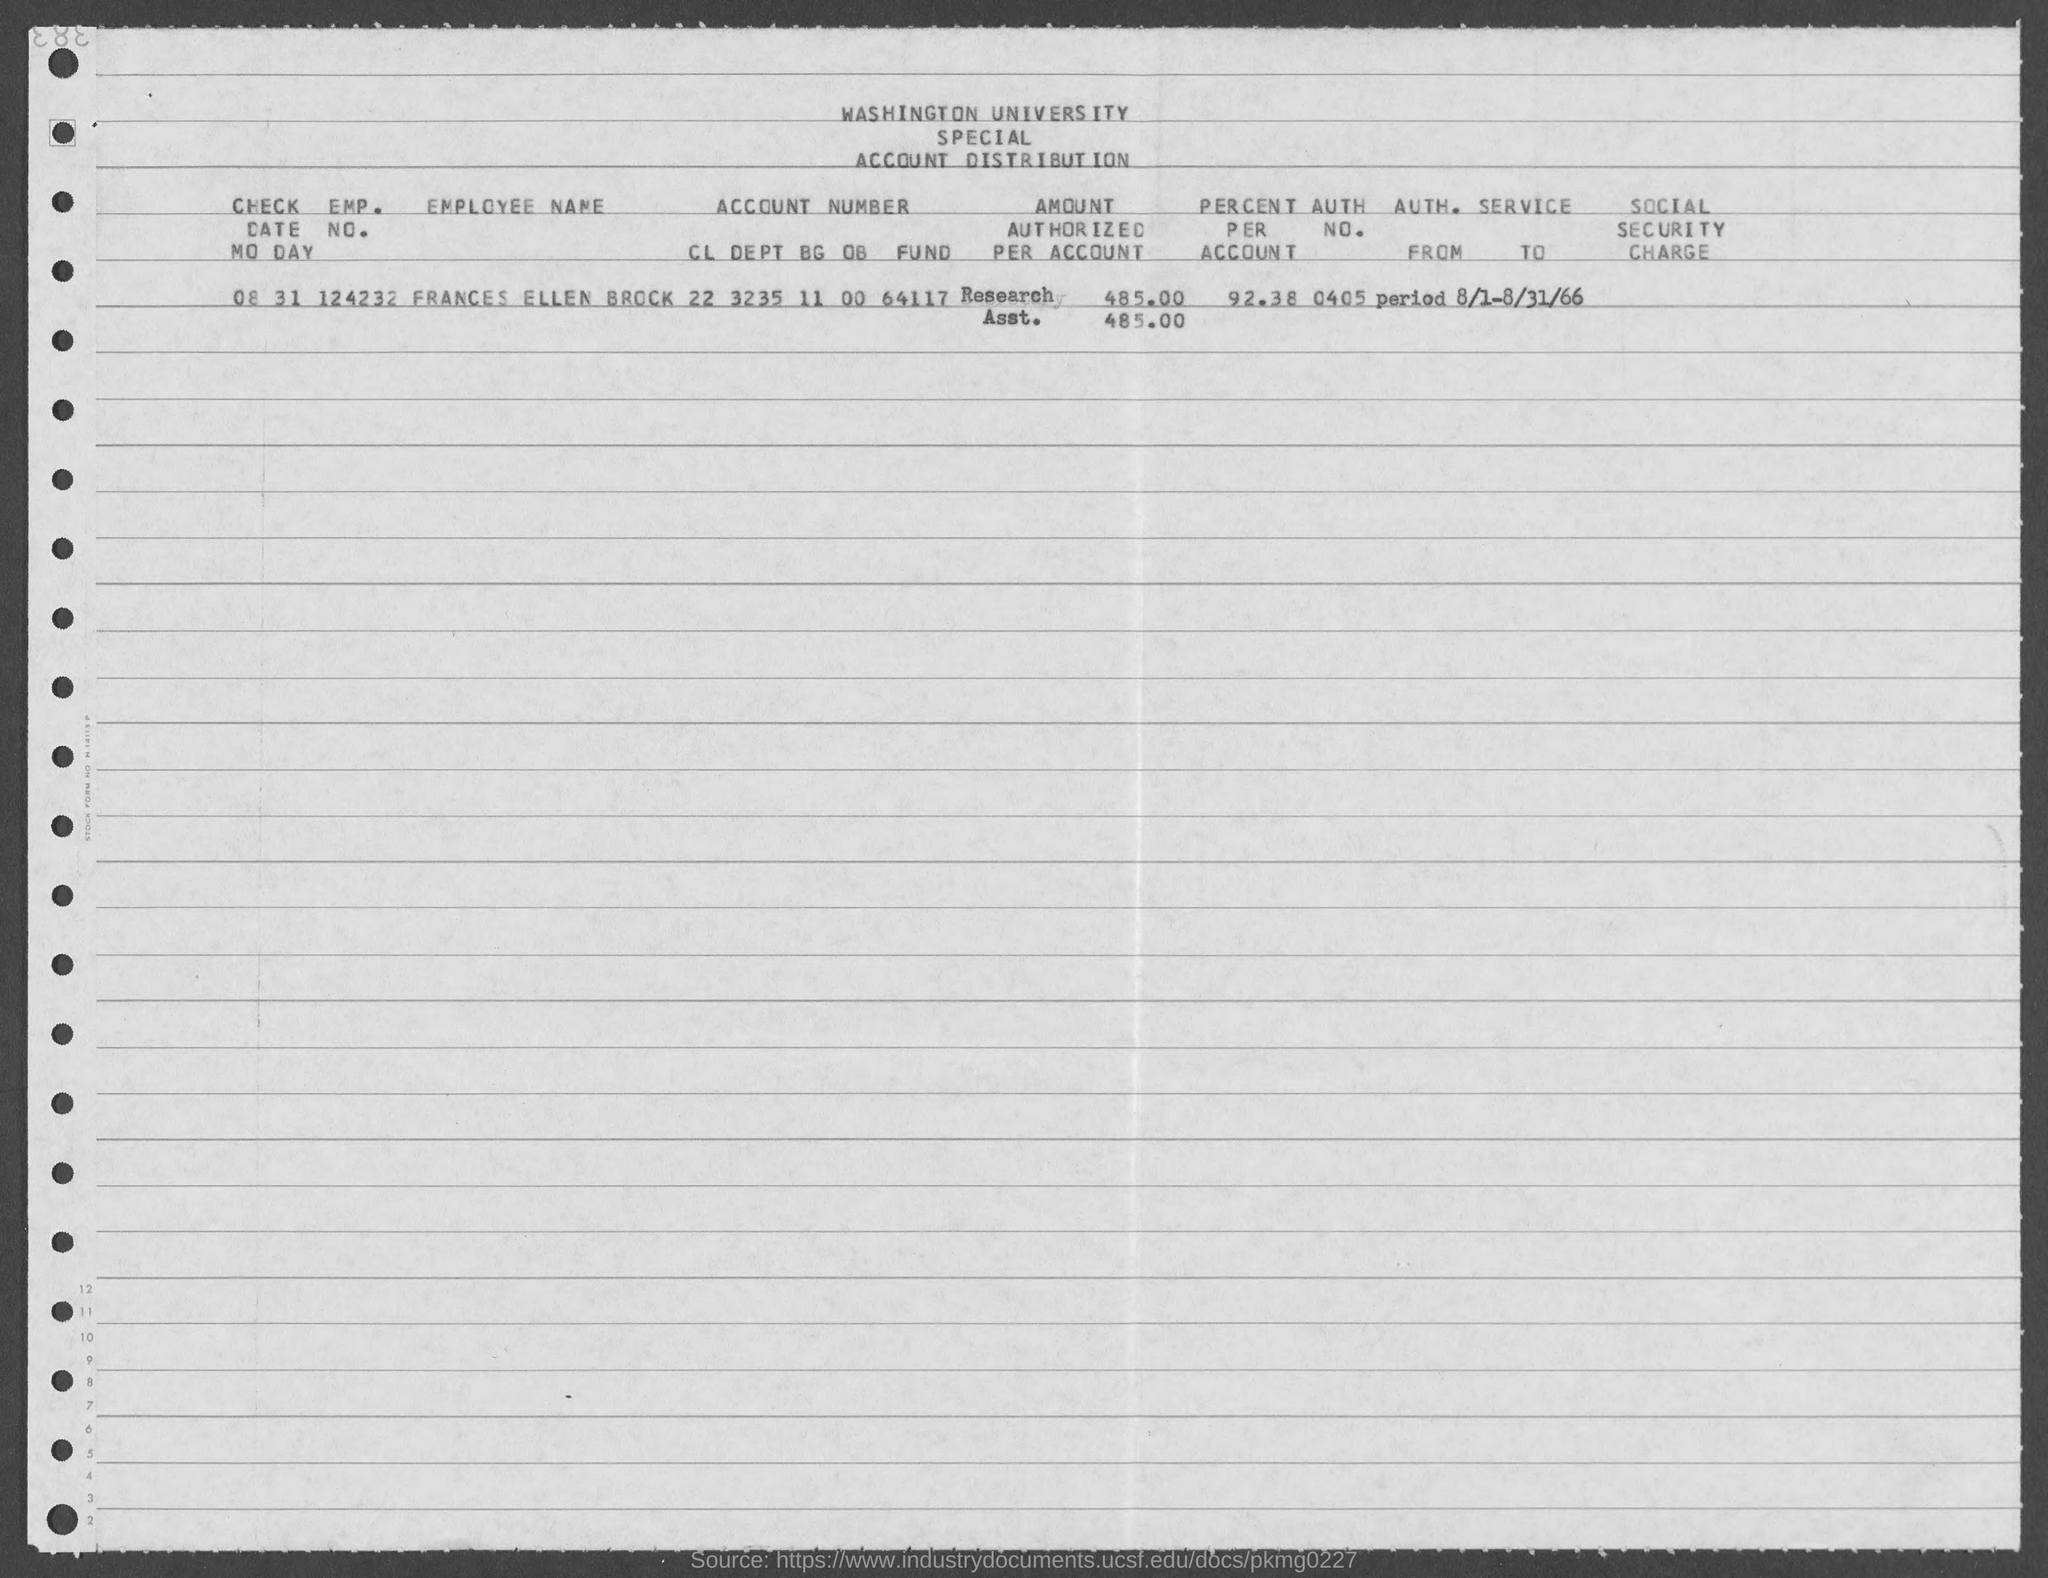Which university's account distirbution is given here?
Your answer should be compact. Washington university. What is the employee name given in the document?
Offer a terse response. FRANCES ELLEN BROCK. What is the EMP. NO. of FRANCES ELLEN BROCK?
Provide a short and direct response. 124232. What is the account number of FRANCES ELLEN BROCK?
Make the answer very short. 22 3235 11 00 64117. What is the amount authorized per account of FRANCES ELLEN BROCK?
Your response must be concise. 485.00. What is the percent per account of FRANCES ELLEN BROCK?
Your answer should be very brief. 92.38. What is the AUTH. NO. of FRANCES ELLEN BROCK?
Make the answer very short. 0405. 